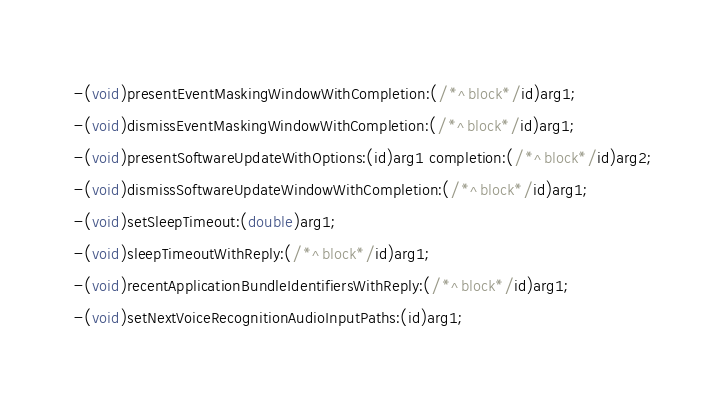<code> <loc_0><loc_0><loc_500><loc_500><_C_>-(void)presentEventMaskingWindowWithCompletion:(/*^block*/id)arg1;
-(void)dismissEventMaskingWindowWithCompletion:(/*^block*/id)arg1;
-(void)presentSoftwareUpdateWithOptions:(id)arg1 completion:(/*^block*/id)arg2;
-(void)dismissSoftwareUpdateWindowWithCompletion:(/*^block*/id)arg1;
-(void)setSleepTimeout:(double)arg1;
-(void)sleepTimeoutWithReply:(/*^block*/id)arg1;
-(void)recentApplicationBundleIdentifiersWithReply:(/*^block*/id)arg1;
-(void)setNextVoiceRecognitionAudioInputPaths:(id)arg1;</code> 